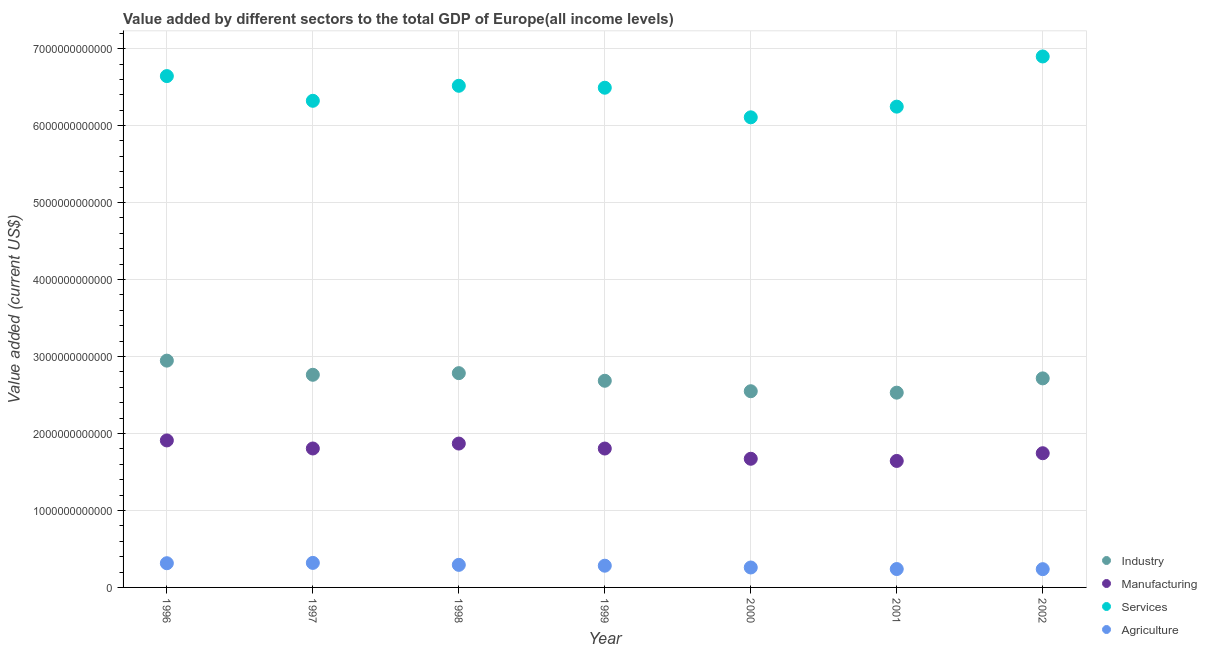How many different coloured dotlines are there?
Ensure brevity in your answer.  4. What is the value added by manufacturing sector in 2000?
Give a very brief answer. 1.67e+12. Across all years, what is the maximum value added by manufacturing sector?
Provide a short and direct response. 1.91e+12. Across all years, what is the minimum value added by agricultural sector?
Give a very brief answer. 2.37e+11. In which year was the value added by manufacturing sector maximum?
Offer a terse response. 1996. In which year was the value added by agricultural sector minimum?
Provide a succinct answer. 2002. What is the total value added by services sector in the graph?
Offer a very short reply. 4.52e+13. What is the difference between the value added by manufacturing sector in 1998 and that in 1999?
Your answer should be compact. 6.47e+1. What is the difference between the value added by industrial sector in 1999 and the value added by manufacturing sector in 2002?
Keep it short and to the point. 9.41e+11. What is the average value added by industrial sector per year?
Provide a short and direct response. 2.71e+12. In the year 2001, what is the difference between the value added by industrial sector and value added by services sector?
Offer a very short reply. -3.72e+12. In how many years, is the value added by agricultural sector greater than 7000000000000 US$?
Provide a short and direct response. 0. What is the ratio of the value added by services sector in 1996 to that in 1997?
Provide a succinct answer. 1.05. Is the difference between the value added by manufacturing sector in 1999 and 2000 greater than the difference between the value added by agricultural sector in 1999 and 2000?
Ensure brevity in your answer.  Yes. What is the difference between the highest and the second highest value added by manufacturing sector?
Provide a succinct answer. 4.05e+1. What is the difference between the highest and the lowest value added by services sector?
Your response must be concise. 7.91e+11. In how many years, is the value added by agricultural sector greater than the average value added by agricultural sector taken over all years?
Keep it short and to the point. 4. Is the sum of the value added by manufacturing sector in 2001 and 2002 greater than the maximum value added by industrial sector across all years?
Give a very brief answer. Yes. Is the value added by agricultural sector strictly greater than the value added by manufacturing sector over the years?
Make the answer very short. No. Is the value added by industrial sector strictly less than the value added by agricultural sector over the years?
Keep it short and to the point. No. What is the difference between two consecutive major ticks on the Y-axis?
Give a very brief answer. 1.00e+12. Are the values on the major ticks of Y-axis written in scientific E-notation?
Keep it short and to the point. No. Does the graph contain grids?
Provide a short and direct response. Yes. Where does the legend appear in the graph?
Keep it short and to the point. Bottom right. What is the title of the graph?
Your answer should be very brief. Value added by different sectors to the total GDP of Europe(all income levels). Does "CO2 damage" appear as one of the legend labels in the graph?
Give a very brief answer. No. What is the label or title of the X-axis?
Your response must be concise. Year. What is the label or title of the Y-axis?
Offer a very short reply. Value added (current US$). What is the Value added (current US$) in Industry in 1996?
Keep it short and to the point. 2.95e+12. What is the Value added (current US$) of Manufacturing in 1996?
Ensure brevity in your answer.  1.91e+12. What is the Value added (current US$) in Services in 1996?
Your response must be concise. 6.64e+12. What is the Value added (current US$) in Agriculture in 1996?
Your response must be concise. 3.15e+11. What is the Value added (current US$) of Industry in 1997?
Offer a terse response. 2.76e+12. What is the Value added (current US$) of Manufacturing in 1997?
Provide a succinct answer. 1.81e+12. What is the Value added (current US$) in Services in 1997?
Provide a short and direct response. 6.32e+12. What is the Value added (current US$) in Agriculture in 1997?
Your answer should be compact. 3.19e+11. What is the Value added (current US$) of Industry in 1998?
Keep it short and to the point. 2.78e+12. What is the Value added (current US$) of Manufacturing in 1998?
Give a very brief answer. 1.87e+12. What is the Value added (current US$) of Services in 1998?
Provide a succinct answer. 6.52e+12. What is the Value added (current US$) of Agriculture in 1998?
Make the answer very short. 2.93e+11. What is the Value added (current US$) in Industry in 1999?
Keep it short and to the point. 2.68e+12. What is the Value added (current US$) of Manufacturing in 1999?
Ensure brevity in your answer.  1.80e+12. What is the Value added (current US$) of Services in 1999?
Your response must be concise. 6.49e+12. What is the Value added (current US$) in Agriculture in 1999?
Provide a succinct answer. 2.82e+11. What is the Value added (current US$) in Industry in 2000?
Provide a succinct answer. 2.55e+12. What is the Value added (current US$) of Manufacturing in 2000?
Offer a very short reply. 1.67e+12. What is the Value added (current US$) of Services in 2000?
Your answer should be very brief. 6.11e+12. What is the Value added (current US$) in Agriculture in 2000?
Your response must be concise. 2.59e+11. What is the Value added (current US$) in Industry in 2001?
Offer a very short reply. 2.53e+12. What is the Value added (current US$) of Manufacturing in 2001?
Your response must be concise. 1.64e+12. What is the Value added (current US$) in Services in 2001?
Provide a short and direct response. 6.25e+12. What is the Value added (current US$) of Agriculture in 2001?
Offer a very short reply. 2.39e+11. What is the Value added (current US$) of Industry in 2002?
Keep it short and to the point. 2.72e+12. What is the Value added (current US$) in Manufacturing in 2002?
Make the answer very short. 1.74e+12. What is the Value added (current US$) of Services in 2002?
Keep it short and to the point. 6.90e+12. What is the Value added (current US$) in Agriculture in 2002?
Provide a short and direct response. 2.37e+11. Across all years, what is the maximum Value added (current US$) in Industry?
Provide a short and direct response. 2.95e+12. Across all years, what is the maximum Value added (current US$) in Manufacturing?
Your response must be concise. 1.91e+12. Across all years, what is the maximum Value added (current US$) in Services?
Keep it short and to the point. 6.90e+12. Across all years, what is the maximum Value added (current US$) of Agriculture?
Offer a very short reply. 3.19e+11. Across all years, what is the minimum Value added (current US$) of Industry?
Ensure brevity in your answer.  2.53e+12. Across all years, what is the minimum Value added (current US$) in Manufacturing?
Provide a succinct answer. 1.64e+12. Across all years, what is the minimum Value added (current US$) of Services?
Offer a very short reply. 6.11e+12. Across all years, what is the minimum Value added (current US$) in Agriculture?
Offer a very short reply. 2.37e+11. What is the total Value added (current US$) in Industry in the graph?
Offer a terse response. 1.90e+13. What is the total Value added (current US$) in Manufacturing in the graph?
Your response must be concise. 1.24e+13. What is the total Value added (current US$) in Services in the graph?
Ensure brevity in your answer.  4.52e+13. What is the total Value added (current US$) of Agriculture in the graph?
Give a very brief answer. 1.94e+12. What is the difference between the Value added (current US$) of Industry in 1996 and that in 1997?
Your answer should be compact. 1.84e+11. What is the difference between the Value added (current US$) in Manufacturing in 1996 and that in 1997?
Your answer should be compact. 1.05e+11. What is the difference between the Value added (current US$) in Services in 1996 and that in 1997?
Ensure brevity in your answer.  3.21e+11. What is the difference between the Value added (current US$) in Agriculture in 1996 and that in 1997?
Offer a very short reply. -4.16e+09. What is the difference between the Value added (current US$) of Industry in 1996 and that in 1998?
Provide a succinct answer. 1.63e+11. What is the difference between the Value added (current US$) of Manufacturing in 1996 and that in 1998?
Offer a terse response. 4.05e+1. What is the difference between the Value added (current US$) in Services in 1996 and that in 1998?
Make the answer very short. 1.26e+11. What is the difference between the Value added (current US$) in Agriculture in 1996 and that in 1998?
Your answer should be compact. 2.14e+1. What is the difference between the Value added (current US$) in Industry in 1996 and that in 1999?
Provide a succinct answer. 2.62e+11. What is the difference between the Value added (current US$) in Manufacturing in 1996 and that in 1999?
Make the answer very short. 1.05e+11. What is the difference between the Value added (current US$) of Services in 1996 and that in 1999?
Your response must be concise. 1.51e+11. What is the difference between the Value added (current US$) of Agriculture in 1996 and that in 1999?
Keep it short and to the point. 3.23e+1. What is the difference between the Value added (current US$) of Industry in 1996 and that in 2000?
Provide a short and direct response. 3.97e+11. What is the difference between the Value added (current US$) of Manufacturing in 1996 and that in 2000?
Your answer should be compact. 2.38e+11. What is the difference between the Value added (current US$) in Services in 1996 and that in 2000?
Make the answer very short. 5.36e+11. What is the difference between the Value added (current US$) in Agriculture in 1996 and that in 2000?
Make the answer very short. 5.55e+1. What is the difference between the Value added (current US$) of Industry in 1996 and that in 2001?
Give a very brief answer. 4.16e+11. What is the difference between the Value added (current US$) in Manufacturing in 1996 and that in 2001?
Offer a terse response. 2.66e+11. What is the difference between the Value added (current US$) of Services in 1996 and that in 2001?
Ensure brevity in your answer.  3.97e+11. What is the difference between the Value added (current US$) in Agriculture in 1996 and that in 2001?
Give a very brief answer. 7.57e+1. What is the difference between the Value added (current US$) in Industry in 1996 and that in 2002?
Your answer should be very brief. 2.31e+11. What is the difference between the Value added (current US$) in Manufacturing in 1996 and that in 2002?
Keep it short and to the point. 1.66e+11. What is the difference between the Value added (current US$) in Services in 1996 and that in 2002?
Your answer should be very brief. -2.55e+11. What is the difference between the Value added (current US$) in Agriculture in 1996 and that in 2002?
Offer a very short reply. 7.74e+1. What is the difference between the Value added (current US$) in Industry in 1997 and that in 1998?
Offer a very short reply. -2.12e+1. What is the difference between the Value added (current US$) in Manufacturing in 1997 and that in 1998?
Your response must be concise. -6.41e+1. What is the difference between the Value added (current US$) in Services in 1997 and that in 1998?
Your answer should be very brief. -1.95e+11. What is the difference between the Value added (current US$) in Agriculture in 1997 and that in 1998?
Your answer should be very brief. 2.56e+1. What is the difference between the Value added (current US$) in Industry in 1997 and that in 1999?
Make the answer very short. 7.77e+1. What is the difference between the Value added (current US$) of Manufacturing in 1997 and that in 1999?
Provide a succinct answer. 5.84e+08. What is the difference between the Value added (current US$) of Services in 1997 and that in 1999?
Your response must be concise. -1.70e+11. What is the difference between the Value added (current US$) in Agriculture in 1997 and that in 1999?
Your response must be concise. 3.65e+1. What is the difference between the Value added (current US$) in Industry in 1997 and that in 2000?
Give a very brief answer. 2.14e+11. What is the difference between the Value added (current US$) in Manufacturing in 1997 and that in 2000?
Your answer should be compact. 1.34e+11. What is the difference between the Value added (current US$) in Services in 1997 and that in 2000?
Offer a terse response. 2.15e+11. What is the difference between the Value added (current US$) of Agriculture in 1997 and that in 2000?
Give a very brief answer. 5.97e+1. What is the difference between the Value added (current US$) of Industry in 1997 and that in 2001?
Your answer should be compact. 2.32e+11. What is the difference between the Value added (current US$) of Manufacturing in 1997 and that in 2001?
Your response must be concise. 1.62e+11. What is the difference between the Value added (current US$) in Services in 1997 and that in 2001?
Offer a very short reply. 7.59e+1. What is the difference between the Value added (current US$) of Agriculture in 1997 and that in 2001?
Ensure brevity in your answer.  7.99e+1. What is the difference between the Value added (current US$) of Industry in 1997 and that in 2002?
Your answer should be compact. 4.67e+1. What is the difference between the Value added (current US$) of Manufacturing in 1997 and that in 2002?
Give a very brief answer. 6.15e+1. What is the difference between the Value added (current US$) of Services in 1997 and that in 2002?
Provide a short and direct response. -5.76e+11. What is the difference between the Value added (current US$) of Agriculture in 1997 and that in 2002?
Ensure brevity in your answer.  8.15e+1. What is the difference between the Value added (current US$) of Industry in 1998 and that in 1999?
Provide a succinct answer. 9.90e+1. What is the difference between the Value added (current US$) in Manufacturing in 1998 and that in 1999?
Your answer should be very brief. 6.47e+1. What is the difference between the Value added (current US$) in Services in 1998 and that in 1999?
Your response must be concise. 2.53e+1. What is the difference between the Value added (current US$) of Agriculture in 1998 and that in 1999?
Keep it short and to the point. 1.09e+1. What is the difference between the Value added (current US$) in Industry in 1998 and that in 2000?
Offer a terse response. 2.35e+11. What is the difference between the Value added (current US$) in Manufacturing in 1998 and that in 2000?
Keep it short and to the point. 1.98e+11. What is the difference between the Value added (current US$) of Services in 1998 and that in 2000?
Offer a very short reply. 4.10e+11. What is the difference between the Value added (current US$) in Agriculture in 1998 and that in 2000?
Your response must be concise. 3.41e+1. What is the difference between the Value added (current US$) of Industry in 1998 and that in 2001?
Your answer should be very brief. 2.53e+11. What is the difference between the Value added (current US$) of Manufacturing in 1998 and that in 2001?
Your answer should be compact. 2.26e+11. What is the difference between the Value added (current US$) of Services in 1998 and that in 2001?
Offer a very short reply. 2.71e+11. What is the difference between the Value added (current US$) of Agriculture in 1998 and that in 2001?
Offer a very short reply. 5.43e+1. What is the difference between the Value added (current US$) of Industry in 1998 and that in 2002?
Offer a very short reply. 6.79e+1. What is the difference between the Value added (current US$) of Manufacturing in 1998 and that in 2002?
Your response must be concise. 1.26e+11. What is the difference between the Value added (current US$) of Services in 1998 and that in 2002?
Provide a short and direct response. -3.81e+11. What is the difference between the Value added (current US$) in Agriculture in 1998 and that in 2002?
Offer a very short reply. 5.60e+1. What is the difference between the Value added (current US$) in Industry in 1999 and that in 2000?
Your answer should be compact. 1.36e+11. What is the difference between the Value added (current US$) in Manufacturing in 1999 and that in 2000?
Ensure brevity in your answer.  1.33e+11. What is the difference between the Value added (current US$) of Services in 1999 and that in 2000?
Give a very brief answer. 3.84e+11. What is the difference between the Value added (current US$) of Agriculture in 1999 and that in 2000?
Give a very brief answer. 2.32e+1. What is the difference between the Value added (current US$) of Industry in 1999 and that in 2001?
Your response must be concise. 1.54e+11. What is the difference between the Value added (current US$) in Manufacturing in 1999 and that in 2001?
Provide a short and direct response. 1.61e+11. What is the difference between the Value added (current US$) of Services in 1999 and that in 2001?
Give a very brief answer. 2.46e+11. What is the difference between the Value added (current US$) of Agriculture in 1999 and that in 2001?
Offer a terse response. 4.34e+1. What is the difference between the Value added (current US$) of Industry in 1999 and that in 2002?
Offer a very short reply. -3.11e+1. What is the difference between the Value added (current US$) of Manufacturing in 1999 and that in 2002?
Offer a very short reply. 6.09e+1. What is the difference between the Value added (current US$) in Services in 1999 and that in 2002?
Keep it short and to the point. -4.06e+11. What is the difference between the Value added (current US$) of Agriculture in 1999 and that in 2002?
Offer a terse response. 4.50e+1. What is the difference between the Value added (current US$) in Industry in 2000 and that in 2001?
Your response must be concise. 1.86e+1. What is the difference between the Value added (current US$) of Manufacturing in 2000 and that in 2001?
Your answer should be very brief. 2.82e+1. What is the difference between the Value added (current US$) in Services in 2000 and that in 2001?
Give a very brief answer. -1.39e+11. What is the difference between the Value added (current US$) in Agriculture in 2000 and that in 2001?
Keep it short and to the point. 2.02e+1. What is the difference between the Value added (current US$) of Industry in 2000 and that in 2002?
Make the answer very short. -1.67e+11. What is the difference between the Value added (current US$) of Manufacturing in 2000 and that in 2002?
Ensure brevity in your answer.  -7.21e+1. What is the difference between the Value added (current US$) in Services in 2000 and that in 2002?
Keep it short and to the point. -7.91e+11. What is the difference between the Value added (current US$) in Agriculture in 2000 and that in 2002?
Your response must be concise. 2.18e+1. What is the difference between the Value added (current US$) in Industry in 2001 and that in 2002?
Ensure brevity in your answer.  -1.85e+11. What is the difference between the Value added (current US$) in Manufacturing in 2001 and that in 2002?
Make the answer very short. -1.00e+11. What is the difference between the Value added (current US$) in Services in 2001 and that in 2002?
Your response must be concise. -6.52e+11. What is the difference between the Value added (current US$) in Agriculture in 2001 and that in 2002?
Your answer should be compact. 1.61e+09. What is the difference between the Value added (current US$) of Industry in 1996 and the Value added (current US$) of Manufacturing in 1997?
Provide a short and direct response. 1.14e+12. What is the difference between the Value added (current US$) of Industry in 1996 and the Value added (current US$) of Services in 1997?
Keep it short and to the point. -3.38e+12. What is the difference between the Value added (current US$) of Industry in 1996 and the Value added (current US$) of Agriculture in 1997?
Ensure brevity in your answer.  2.63e+12. What is the difference between the Value added (current US$) in Manufacturing in 1996 and the Value added (current US$) in Services in 1997?
Make the answer very short. -4.41e+12. What is the difference between the Value added (current US$) in Manufacturing in 1996 and the Value added (current US$) in Agriculture in 1997?
Your answer should be compact. 1.59e+12. What is the difference between the Value added (current US$) in Services in 1996 and the Value added (current US$) in Agriculture in 1997?
Keep it short and to the point. 6.32e+12. What is the difference between the Value added (current US$) of Industry in 1996 and the Value added (current US$) of Manufacturing in 1998?
Your response must be concise. 1.08e+12. What is the difference between the Value added (current US$) of Industry in 1996 and the Value added (current US$) of Services in 1998?
Your response must be concise. -3.57e+12. What is the difference between the Value added (current US$) in Industry in 1996 and the Value added (current US$) in Agriculture in 1998?
Offer a very short reply. 2.65e+12. What is the difference between the Value added (current US$) of Manufacturing in 1996 and the Value added (current US$) of Services in 1998?
Your response must be concise. -4.61e+12. What is the difference between the Value added (current US$) of Manufacturing in 1996 and the Value added (current US$) of Agriculture in 1998?
Give a very brief answer. 1.62e+12. What is the difference between the Value added (current US$) in Services in 1996 and the Value added (current US$) in Agriculture in 1998?
Your answer should be compact. 6.35e+12. What is the difference between the Value added (current US$) in Industry in 1996 and the Value added (current US$) in Manufacturing in 1999?
Make the answer very short. 1.14e+12. What is the difference between the Value added (current US$) in Industry in 1996 and the Value added (current US$) in Services in 1999?
Provide a short and direct response. -3.55e+12. What is the difference between the Value added (current US$) of Industry in 1996 and the Value added (current US$) of Agriculture in 1999?
Give a very brief answer. 2.66e+12. What is the difference between the Value added (current US$) of Manufacturing in 1996 and the Value added (current US$) of Services in 1999?
Make the answer very short. -4.58e+12. What is the difference between the Value added (current US$) in Manufacturing in 1996 and the Value added (current US$) in Agriculture in 1999?
Make the answer very short. 1.63e+12. What is the difference between the Value added (current US$) in Services in 1996 and the Value added (current US$) in Agriculture in 1999?
Keep it short and to the point. 6.36e+12. What is the difference between the Value added (current US$) of Industry in 1996 and the Value added (current US$) of Manufacturing in 2000?
Keep it short and to the point. 1.27e+12. What is the difference between the Value added (current US$) of Industry in 1996 and the Value added (current US$) of Services in 2000?
Ensure brevity in your answer.  -3.16e+12. What is the difference between the Value added (current US$) in Industry in 1996 and the Value added (current US$) in Agriculture in 2000?
Ensure brevity in your answer.  2.69e+12. What is the difference between the Value added (current US$) in Manufacturing in 1996 and the Value added (current US$) in Services in 2000?
Provide a short and direct response. -4.20e+12. What is the difference between the Value added (current US$) of Manufacturing in 1996 and the Value added (current US$) of Agriculture in 2000?
Offer a terse response. 1.65e+12. What is the difference between the Value added (current US$) of Services in 1996 and the Value added (current US$) of Agriculture in 2000?
Keep it short and to the point. 6.38e+12. What is the difference between the Value added (current US$) of Industry in 1996 and the Value added (current US$) of Manufacturing in 2001?
Your answer should be very brief. 1.30e+12. What is the difference between the Value added (current US$) in Industry in 1996 and the Value added (current US$) in Services in 2001?
Your answer should be very brief. -3.30e+12. What is the difference between the Value added (current US$) of Industry in 1996 and the Value added (current US$) of Agriculture in 2001?
Your answer should be very brief. 2.71e+12. What is the difference between the Value added (current US$) in Manufacturing in 1996 and the Value added (current US$) in Services in 2001?
Offer a very short reply. -4.34e+12. What is the difference between the Value added (current US$) of Manufacturing in 1996 and the Value added (current US$) of Agriculture in 2001?
Provide a short and direct response. 1.67e+12. What is the difference between the Value added (current US$) of Services in 1996 and the Value added (current US$) of Agriculture in 2001?
Provide a short and direct response. 6.40e+12. What is the difference between the Value added (current US$) in Industry in 1996 and the Value added (current US$) in Manufacturing in 2002?
Your answer should be very brief. 1.20e+12. What is the difference between the Value added (current US$) in Industry in 1996 and the Value added (current US$) in Services in 2002?
Ensure brevity in your answer.  -3.95e+12. What is the difference between the Value added (current US$) in Industry in 1996 and the Value added (current US$) in Agriculture in 2002?
Give a very brief answer. 2.71e+12. What is the difference between the Value added (current US$) of Manufacturing in 1996 and the Value added (current US$) of Services in 2002?
Provide a succinct answer. -4.99e+12. What is the difference between the Value added (current US$) in Manufacturing in 1996 and the Value added (current US$) in Agriculture in 2002?
Provide a short and direct response. 1.67e+12. What is the difference between the Value added (current US$) in Services in 1996 and the Value added (current US$) in Agriculture in 2002?
Your answer should be very brief. 6.41e+12. What is the difference between the Value added (current US$) of Industry in 1997 and the Value added (current US$) of Manufacturing in 1998?
Offer a very short reply. 8.93e+11. What is the difference between the Value added (current US$) of Industry in 1997 and the Value added (current US$) of Services in 1998?
Ensure brevity in your answer.  -3.75e+12. What is the difference between the Value added (current US$) of Industry in 1997 and the Value added (current US$) of Agriculture in 1998?
Keep it short and to the point. 2.47e+12. What is the difference between the Value added (current US$) in Manufacturing in 1997 and the Value added (current US$) in Services in 1998?
Give a very brief answer. -4.71e+12. What is the difference between the Value added (current US$) of Manufacturing in 1997 and the Value added (current US$) of Agriculture in 1998?
Make the answer very short. 1.51e+12. What is the difference between the Value added (current US$) of Services in 1997 and the Value added (current US$) of Agriculture in 1998?
Provide a succinct answer. 6.03e+12. What is the difference between the Value added (current US$) in Industry in 1997 and the Value added (current US$) in Manufacturing in 1999?
Your response must be concise. 9.58e+11. What is the difference between the Value added (current US$) in Industry in 1997 and the Value added (current US$) in Services in 1999?
Offer a very short reply. -3.73e+12. What is the difference between the Value added (current US$) in Industry in 1997 and the Value added (current US$) in Agriculture in 1999?
Your answer should be compact. 2.48e+12. What is the difference between the Value added (current US$) in Manufacturing in 1997 and the Value added (current US$) in Services in 1999?
Make the answer very short. -4.69e+12. What is the difference between the Value added (current US$) in Manufacturing in 1997 and the Value added (current US$) in Agriculture in 1999?
Provide a short and direct response. 1.52e+12. What is the difference between the Value added (current US$) in Services in 1997 and the Value added (current US$) in Agriculture in 1999?
Your answer should be compact. 6.04e+12. What is the difference between the Value added (current US$) in Industry in 1997 and the Value added (current US$) in Manufacturing in 2000?
Offer a very short reply. 1.09e+12. What is the difference between the Value added (current US$) in Industry in 1997 and the Value added (current US$) in Services in 2000?
Your answer should be compact. -3.35e+12. What is the difference between the Value added (current US$) of Industry in 1997 and the Value added (current US$) of Agriculture in 2000?
Provide a succinct answer. 2.50e+12. What is the difference between the Value added (current US$) of Manufacturing in 1997 and the Value added (current US$) of Services in 2000?
Keep it short and to the point. -4.30e+12. What is the difference between the Value added (current US$) of Manufacturing in 1997 and the Value added (current US$) of Agriculture in 2000?
Provide a short and direct response. 1.55e+12. What is the difference between the Value added (current US$) in Services in 1997 and the Value added (current US$) in Agriculture in 2000?
Keep it short and to the point. 6.06e+12. What is the difference between the Value added (current US$) of Industry in 1997 and the Value added (current US$) of Manufacturing in 2001?
Provide a succinct answer. 1.12e+12. What is the difference between the Value added (current US$) in Industry in 1997 and the Value added (current US$) in Services in 2001?
Give a very brief answer. -3.48e+12. What is the difference between the Value added (current US$) of Industry in 1997 and the Value added (current US$) of Agriculture in 2001?
Make the answer very short. 2.52e+12. What is the difference between the Value added (current US$) of Manufacturing in 1997 and the Value added (current US$) of Services in 2001?
Provide a short and direct response. -4.44e+12. What is the difference between the Value added (current US$) in Manufacturing in 1997 and the Value added (current US$) in Agriculture in 2001?
Your answer should be compact. 1.57e+12. What is the difference between the Value added (current US$) of Services in 1997 and the Value added (current US$) of Agriculture in 2001?
Provide a short and direct response. 6.08e+12. What is the difference between the Value added (current US$) of Industry in 1997 and the Value added (current US$) of Manufacturing in 2002?
Ensure brevity in your answer.  1.02e+12. What is the difference between the Value added (current US$) of Industry in 1997 and the Value added (current US$) of Services in 2002?
Make the answer very short. -4.14e+12. What is the difference between the Value added (current US$) of Industry in 1997 and the Value added (current US$) of Agriculture in 2002?
Your response must be concise. 2.53e+12. What is the difference between the Value added (current US$) in Manufacturing in 1997 and the Value added (current US$) in Services in 2002?
Ensure brevity in your answer.  -5.09e+12. What is the difference between the Value added (current US$) of Manufacturing in 1997 and the Value added (current US$) of Agriculture in 2002?
Make the answer very short. 1.57e+12. What is the difference between the Value added (current US$) of Services in 1997 and the Value added (current US$) of Agriculture in 2002?
Give a very brief answer. 6.09e+12. What is the difference between the Value added (current US$) of Industry in 1998 and the Value added (current US$) of Manufacturing in 1999?
Ensure brevity in your answer.  9.79e+11. What is the difference between the Value added (current US$) in Industry in 1998 and the Value added (current US$) in Services in 1999?
Your answer should be very brief. -3.71e+12. What is the difference between the Value added (current US$) of Industry in 1998 and the Value added (current US$) of Agriculture in 1999?
Offer a very short reply. 2.50e+12. What is the difference between the Value added (current US$) of Manufacturing in 1998 and the Value added (current US$) of Services in 1999?
Keep it short and to the point. -4.62e+12. What is the difference between the Value added (current US$) in Manufacturing in 1998 and the Value added (current US$) in Agriculture in 1999?
Give a very brief answer. 1.59e+12. What is the difference between the Value added (current US$) of Services in 1998 and the Value added (current US$) of Agriculture in 1999?
Keep it short and to the point. 6.24e+12. What is the difference between the Value added (current US$) of Industry in 1998 and the Value added (current US$) of Manufacturing in 2000?
Provide a succinct answer. 1.11e+12. What is the difference between the Value added (current US$) of Industry in 1998 and the Value added (current US$) of Services in 2000?
Offer a terse response. -3.32e+12. What is the difference between the Value added (current US$) of Industry in 1998 and the Value added (current US$) of Agriculture in 2000?
Offer a very short reply. 2.52e+12. What is the difference between the Value added (current US$) of Manufacturing in 1998 and the Value added (current US$) of Services in 2000?
Your answer should be very brief. -4.24e+12. What is the difference between the Value added (current US$) in Manufacturing in 1998 and the Value added (current US$) in Agriculture in 2000?
Your answer should be very brief. 1.61e+12. What is the difference between the Value added (current US$) in Services in 1998 and the Value added (current US$) in Agriculture in 2000?
Provide a short and direct response. 6.26e+12. What is the difference between the Value added (current US$) in Industry in 1998 and the Value added (current US$) in Manufacturing in 2001?
Offer a very short reply. 1.14e+12. What is the difference between the Value added (current US$) of Industry in 1998 and the Value added (current US$) of Services in 2001?
Your answer should be very brief. -3.46e+12. What is the difference between the Value added (current US$) of Industry in 1998 and the Value added (current US$) of Agriculture in 2001?
Offer a very short reply. 2.55e+12. What is the difference between the Value added (current US$) in Manufacturing in 1998 and the Value added (current US$) in Services in 2001?
Your response must be concise. -4.38e+12. What is the difference between the Value added (current US$) of Manufacturing in 1998 and the Value added (current US$) of Agriculture in 2001?
Give a very brief answer. 1.63e+12. What is the difference between the Value added (current US$) in Services in 1998 and the Value added (current US$) in Agriculture in 2001?
Offer a very short reply. 6.28e+12. What is the difference between the Value added (current US$) in Industry in 1998 and the Value added (current US$) in Manufacturing in 2002?
Make the answer very short. 1.04e+12. What is the difference between the Value added (current US$) of Industry in 1998 and the Value added (current US$) of Services in 2002?
Provide a short and direct response. -4.11e+12. What is the difference between the Value added (current US$) in Industry in 1998 and the Value added (current US$) in Agriculture in 2002?
Give a very brief answer. 2.55e+12. What is the difference between the Value added (current US$) in Manufacturing in 1998 and the Value added (current US$) in Services in 2002?
Provide a succinct answer. -5.03e+12. What is the difference between the Value added (current US$) in Manufacturing in 1998 and the Value added (current US$) in Agriculture in 2002?
Give a very brief answer. 1.63e+12. What is the difference between the Value added (current US$) in Services in 1998 and the Value added (current US$) in Agriculture in 2002?
Provide a short and direct response. 6.28e+12. What is the difference between the Value added (current US$) of Industry in 1999 and the Value added (current US$) of Manufacturing in 2000?
Your response must be concise. 1.01e+12. What is the difference between the Value added (current US$) of Industry in 1999 and the Value added (current US$) of Services in 2000?
Provide a short and direct response. -3.42e+12. What is the difference between the Value added (current US$) of Industry in 1999 and the Value added (current US$) of Agriculture in 2000?
Ensure brevity in your answer.  2.43e+12. What is the difference between the Value added (current US$) in Manufacturing in 1999 and the Value added (current US$) in Services in 2000?
Give a very brief answer. -4.30e+12. What is the difference between the Value added (current US$) of Manufacturing in 1999 and the Value added (current US$) of Agriculture in 2000?
Ensure brevity in your answer.  1.55e+12. What is the difference between the Value added (current US$) of Services in 1999 and the Value added (current US$) of Agriculture in 2000?
Make the answer very short. 6.23e+12. What is the difference between the Value added (current US$) of Industry in 1999 and the Value added (current US$) of Manufacturing in 2001?
Provide a short and direct response. 1.04e+12. What is the difference between the Value added (current US$) of Industry in 1999 and the Value added (current US$) of Services in 2001?
Ensure brevity in your answer.  -3.56e+12. What is the difference between the Value added (current US$) of Industry in 1999 and the Value added (current US$) of Agriculture in 2001?
Provide a short and direct response. 2.45e+12. What is the difference between the Value added (current US$) of Manufacturing in 1999 and the Value added (current US$) of Services in 2001?
Your answer should be compact. -4.44e+12. What is the difference between the Value added (current US$) of Manufacturing in 1999 and the Value added (current US$) of Agriculture in 2001?
Keep it short and to the point. 1.57e+12. What is the difference between the Value added (current US$) of Services in 1999 and the Value added (current US$) of Agriculture in 2001?
Ensure brevity in your answer.  6.25e+12. What is the difference between the Value added (current US$) in Industry in 1999 and the Value added (current US$) in Manufacturing in 2002?
Your response must be concise. 9.41e+11. What is the difference between the Value added (current US$) in Industry in 1999 and the Value added (current US$) in Services in 2002?
Provide a short and direct response. -4.21e+12. What is the difference between the Value added (current US$) of Industry in 1999 and the Value added (current US$) of Agriculture in 2002?
Provide a short and direct response. 2.45e+12. What is the difference between the Value added (current US$) in Manufacturing in 1999 and the Value added (current US$) in Services in 2002?
Your response must be concise. -5.09e+12. What is the difference between the Value added (current US$) in Manufacturing in 1999 and the Value added (current US$) in Agriculture in 2002?
Provide a short and direct response. 1.57e+12. What is the difference between the Value added (current US$) of Services in 1999 and the Value added (current US$) of Agriculture in 2002?
Your answer should be very brief. 6.25e+12. What is the difference between the Value added (current US$) in Industry in 2000 and the Value added (current US$) in Manufacturing in 2001?
Keep it short and to the point. 9.06e+11. What is the difference between the Value added (current US$) in Industry in 2000 and the Value added (current US$) in Services in 2001?
Your answer should be very brief. -3.70e+12. What is the difference between the Value added (current US$) in Industry in 2000 and the Value added (current US$) in Agriculture in 2001?
Your response must be concise. 2.31e+12. What is the difference between the Value added (current US$) in Manufacturing in 2000 and the Value added (current US$) in Services in 2001?
Offer a very short reply. -4.57e+12. What is the difference between the Value added (current US$) of Manufacturing in 2000 and the Value added (current US$) of Agriculture in 2001?
Ensure brevity in your answer.  1.43e+12. What is the difference between the Value added (current US$) of Services in 2000 and the Value added (current US$) of Agriculture in 2001?
Your answer should be very brief. 5.87e+12. What is the difference between the Value added (current US$) of Industry in 2000 and the Value added (current US$) of Manufacturing in 2002?
Provide a short and direct response. 8.05e+11. What is the difference between the Value added (current US$) of Industry in 2000 and the Value added (current US$) of Services in 2002?
Give a very brief answer. -4.35e+12. What is the difference between the Value added (current US$) in Industry in 2000 and the Value added (current US$) in Agriculture in 2002?
Offer a terse response. 2.31e+12. What is the difference between the Value added (current US$) in Manufacturing in 2000 and the Value added (current US$) in Services in 2002?
Keep it short and to the point. -5.23e+12. What is the difference between the Value added (current US$) in Manufacturing in 2000 and the Value added (current US$) in Agriculture in 2002?
Your response must be concise. 1.43e+12. What is the difference between the Value added (current US$) of Services in 2000 and the Value added (current US$) of Agriculture in 2002?
Provide a short and direct response. 5.87e+12. What is the difference between the Value added (current US$) of Industry in 2001 and the Value added (current US$) of Manufacturing in 2002?
Ensure brevity in your answer.  7.87e+11. What is the difference between the Value added (current US$) in Industry in 2001 and the Value added (current US$) in Services in 2002?
Your answer should be very brief. -4.37e+12. What is the difference between the Value added (current US$) in Industry in 2001 and the Value added (current US$) in Agriculture in 2002?
Keep it short and to the point. 2.29e+12. What is the difference between the Value added (current US$) in Manufacturing in 2001 and the Value added (current US$) in Services in 2002?
Your response must be concise. -5.25e+12. What is the difference between the Value added (current US$) in Manufacturing in 2001 and the Value added (current US$) in Agriculture in 2002?
Keep it short and to the point. 1.41e+12. What is the difference between the Value added (current US$) of Services in 2001 and the Value added (current US$) of Agriculture in 2002?
Your response must be concise. 6.01e+12. What is the average Value added (current US$) in Industry per year?
Offer a terse response. 2.71e+12. What is the average Value added (current US$) in Manufacturing per year?
Give a very brief answer. 1.78e+12. What is the average Value added (current US$) of Services per year?
Keep it short and to the point. 6.46e+12. What is the average Value added (current US$) in Agriculture per year?
Your answer should be compact. 2.78e+11. In the year 1996, what is the difference between the Value added (current US$) in Industry and Value added (current US$) in Manufacturing?
Provide a succinct answer. 1.04e+12. In the year 1996, what is the difference between the Value added (current US$) in Industry and Value added (current US$) in Services?
Offer a terse response. -3.70e+12. In the year 1996, what is the difference between the Value added (current US$) of Industry and Value added (current US$) of Agriculture?
Provide a short and direct response. 2.63e+12. In the year 1996, what is the difference between the Value added (current US$) of Manufacturing and Value added (current US$) of Services?
Your response must be concise. -4.73e+12. In the year 1996, what is the difference between the Value added (current US$) in Manufacturing and Value added (current US$) in Agriculture?
Offer a terse response. 1.60e+12. In the year 1996, what is the difference between the Value added (current US$) of Services and Value added (current US$) of Agriculture?
Offer a very short reply. 6.33e+12. In the year 1997, what is the difference between the Value added (current US$) of Industry and Value added (current US$) of Manufacturing?
Provide a short and direct response. 9.57e+11. In the year 1997, what is the difference between the Value added (current US$) in Industry and Value added (current US$) in Services?
Ensure brevity in your answer.  -3.56e+12. In the year 1997, what is the difference between the Value added (current US$) of Industry and Value added (current US$) of Agriculture?
Provide a short and direct response. 2.44e+12. In the year 1997, what is the difference between the Value added (current US$) of Manufacturing and Value added (current US$) of Services?
Provide a succinct answer. -4.52e+12. In the year 1997, what is the difference between the Value added (current US$) in Manufacturing and Value added (current US$) in Agriculture?
Your answer should be very brief. 1.49e+12. In the year 1997, what is the difference between the Value added (current US$) of Services and Value added (current US$) of Agriculture?
Your answer should be compact. 6.00e+12. In the year 1998, what is the difference between the Value added (current US$) in Industry and Value added (current US$) in Manufacturing?
Provide a short and direct response. 9.15e+11. In the year 1998, what is the difference between the Value added (current US$) in Industry and Value added (current US$) in Services?
Your response must be concise. -3.73e+12. In the year 1998, what is the difference between the Value added (current US$) in Industry and Value added (current US$) in Agriculture?
Offer a very short reply. 2.49e+12. In the year 1998, what is the difference between the Value added (current US$) in Manufacturing and Value added (current US$) in Services?
Ensure brevity in your answer.  -4.65e+12. In the year 1998, what is the difference between the Value added (current US$) in Manufacturing and Value added (current US$) in Agriculture?
Your answer should be very brief. 1.58e+12. In the year 1998, what is the difference between the Value added (current US$) in Services and Value added (current US$) in Agriculture?
Your answer should be compact. 6.22e+12. In the year 1999, what is the difference between the Value added (current US$) of Industry and Value added (current US$) of Manufacturing?
Provide a succinct answer. 8.80e+11. In the year 1999, what is the difference between the Value added (current US$) in Industry and Value added (current US$) in Services?
Provide a short and direct response. -3.81e+12. In the year 1999, what is the difference between the Value added (current US$) of Industry and Value added (current US$) of Agriculture?
Provide a succinct answer. 2.40e+12. In the year 1999, what is the difference between the Value added (current US$) in Manufacturing and Value added (current US$) in Services?
Provide a short and direct response. -4.69e+12. In the year 1999, what is the difference between the Value added (current US$) of Manufacturing and Value added (current US$) of Agriculture?
Keep it short and to the point. 1.52e+12. In the year 1999, what is the difference between the Value added (current US$) in Services and Value added (current US$) in Agriculture?
Provide a short and direct response. 6.21e+12. In the year 2000, what is the difference between the Value added (current US$) of Industry and Value added (current US$) of Manufacturing?
Your answer should be very brief. 8.77e+11. In the year 2000, what is the difference between the Value added (current US$) of Industry and Value added (current US$) of Services?
Your response must be concise. -3.56e+12. In the year 2000, what is the difference between the Value added (current US$) in Industry and Value added (current US$) in Agriculture?
Your response must be concise. 2.29e+12. In the year 2000, what is the difference between the Value added (current US$) in Manufacturing and Value added (current US$) in Services?
Your response must be concise. -4.44e+12. In the year 2000, what is the difference between the Value added (current US$) of Manufacturing and Value added (current US$) of Agriculture?
Keep it short and to the point. 1.41e+12. In the year 2000, what is the difference between the Value added (current US$) of Services and Value added (current US$) of Agriculture?
Offer a very short reply. 5.85e+12. In the year 2001, what is the difference between the Value added (current US$) in Industry and Value added (current US$) in Manufacturing?
Make the answer very short. 8.87e+11. In the year 2001, what is the difference between the Value added (current US$) of Industry and Value added (current US$) of Services?
Provide a succinct answer. -3.72e+12. In the year 2001, what is the difference between the Value added (current US$) in Industry and Value added (current US$) in Agriculture?
Keep it short and to the point. 2.29e+12. In the year 2001, what is the difference between the Value added (current US$) of Manufacturing and Value added (current US$) of Services?
Your answer should be very brief. -4.60e+12. In the year 2001, what is the difference between the Value added (current US$) in Manufacturing and Value added (current US$) in Agriculture?
Your response must be concise. 1.40e+12. In the year 2001, what is the difference between the Value added (current US$) of Services and Value added (current US$) of Agriculture?
Ensure brevity in your answer.  6.01e+12. In the year 2002, what is the difference between the Value added (current US$) of Industry and Value added (current US$) of Manufacturing?
Give a very brief answer. 9.72e+11. In the year 2002, what is the difference between the Value added (current US$) in Industry and Value added (current US$) in Services?
Give a very brief answer. -4.18e+12. In the year 2002, what is the difference between the Value added (current US$) of Industry and Value added (current US$) of Agriculture?
Keep it short and to the point. 2.48e+12. In the year 2002, what is the difference between the Value added (current US$) of Manufacturing and Value added (current US$) of Services?
Offer a very short reply. -5.15e+12. In the year 2002, what is the difference between the Value added (current US$) in Manufacturing and Value added (current US$) in Agriculture?
Make the answer very short. 1.51e+12. In the year 2002, what is the difference between the Value added (current US$) of Services and Value added (current US$) of Agriculture?
Offer a very short reply. 6.66e+12. What is the ratio of the Value added (current US$) of Industry in 1996 to that in 1997?
Make the answer very short. 1.07. What is the ratio of the Value added (current US$) of Manufacturing in 1996 to that in 1997?
Your answer should be very brief. 1.06. What is the ratio of the Value added (current US$) in Services in 1996 to that in 1997?
Provide a succinct answer. 1.05. What is the ratio of the Value added (current US$) of Agriculture in 1996 to that in 1997?
Your answer should be very brief. 0.99. What is the ratio of the Value added (current US$) in Industry in 1996 to that in 1998?
Offer a terse response. 1.06. What is the ratio of the Value added (current US$) of Manufacturing in 1996 to that in 1998?
Give a very brief answer. 1.02. What is the ratio of the Value added (current US$) of Services in 1996 to that in 1998?
Make the answer very short. 1.02. What is the ratio of the Value added (current US$) in Agriculture in 1996 to that in 1998?
Offer a very short reply. 1.07. What is the ratio of the Value added (current US$) in Industry in 1996 to that in 1999?
Provide a short and direct response. 1.1. What is the ratio of the Value added (current US$) in Manufacturing in 1996 to that in 1999?
Make the answer very short. 1.06. What is the ratio of the Value added (current US$) of Services in 1996 to that in 1999?
Your answer should be very brief. 1.02. What is the ratio of the Value added (current US$) of Agriculture in 1996 to that in 1999?
Provide a short and direct response. 1.11. What is the ratio of the Value added (current US$) of Industry in 1996 to that in 2000?
Provide a succinct answer. 1.16. What is the ratio of the Value added (current US$) in Manufacturing in 1996 to that in 2000?
Your response must be concise. 1.14. What is the ratio of the Value added (current US$) of Services in 1996 to that in 2000?
Offer a terse response. 1.09. What is the ratio of the Value added (current US$) of Agriculture in 1996 to that in 2000?
Give a very brief answer. 1.21. What is the ratio of the Value added (current US$) in Industry in 1996 to that in 2001?
Provide a succinct answer. 1.16. What is the ratio of the Value added (current US$) of Manufacturing in 1996 to that in 2001?
Your response must be concise. 1.16. What is the ratio of the Value added (current US$) of Services in 1996 to that in 2001?
Offer a very short reply. 1.06. What is the ratio of the Value added (current US$) of Agriculture in 1996 to that in 2001?
Your response must be concise. 1.32. What is the ratio of the Value added (current US$) in Industry in 1996 to that in 2002?
Make the answer very short. 1.08. What is the ratio of the Value added (current US$) in Manufacturing in 1996 to that in 2002?
Provide a succinct answer. 1.1. What is the ratio of the Value added (current US$) of Services in 1996 to that in 2002?
Make the answer very short. 0.96. What is the ratio of the Value added (current US$) of Agriculture in 1996 to that in 2002?
Your answer should be very brief. 1.33. What is the ratio of the Value added (current US$) of Industry in 1997 to that in 1998?
Your answer should be very brief. 0.99. What is the ratio of the Value added (current US$) of Manufacturing in 1997 to that in 1998?
Your response must be concise. 0.97. What is the ratio of the Value added (current US$) in Services in 1997 to that in 1998?
Offer a very short reply. 0.97. What is the ratio of the Value added (current US$) of Agriculture in 1997 to that in 1998?
Ensure brevity in your answer.  1.09. What is the ratio of the Value added (current US$) in Industry in 1997 to that in 1999?
Offer a very short reply. 1.03. What is the ratio of the Value added (current US$) in Services in 1997 to that in 1999?
Provide a short and direct response. 0.97. What is the ratio of the Value added (current US$) of Agriculture in 1997 to that in 1999?
Keep it short and to the point. 1.13. What is the ratio of the Value added (current US$) of Industry in 1997 to that in 2000?
Give a very brief answer. 1.08. What is the ratio of the Value added (current US$) in Manufacturing in 1997 to that in 2000?
Your answer should be compact. 1.08. What is the ratio of the Value added (current US$) of Services in 1997 to that in 2000?
Offer a very short reply. 1.04. What is the ratio of the Value added (current US$) in Agriculture in 1997 to that in 2000?
Your answer should be very brief. 1.23. What is the ratio of the Value added (current US$) in Industry in 1997 to that in 2001?
Provide a short and direct response. 1.09. What is the ratio of the Value added (current US$) in Manufacturing in 1997 to that in 2001?
Provide a short and direct response. 1.1. What is the ratio of the Value added (current US$) of Services in 1997 to that in 2001?
Ensure brevity in your answer.  1.01. What is the ratio of the Value added (current US$) of Agriculture in 1997 to that in 2001?
Provide a short and direct response. 1.33. What is the ratio of the Value added (current US$) of Industry in 1997 to that in 2002?
Offer a very short reply. 1.02. What is the ratio of the Value added (current US$) of Manufacturing in 1997 to that in 2002?
Offer a very short reply. 1.04. What is the ratio of the Value added (current US$) of Services in 1997 to that in 2002?
Keep it short and to the point. 0.92. What is the ratio of the Value added (current US$) in Agriculture in 1997 to that in 2002?
Keep it short and to the point. 1.34. What is the ratio of the Value added (current US$) in Industry in 1998 to that in 1999?
Give a very brief answer. 1.04. What is the ratio of the Value added (current US$) in Manufacturing in 1998 to that in 1999?
Provide a short and direct response. 1.04. What is the ratio of the Value added (current US$) in Agriculture in 1998 to that in 1999?
Provide a short and direct response. 1.04. What is the ratio of the Value added (current US$) in Industry in 1998 to that in 2000?
Provide a short and direct response. 1.09. What is the ratio of the Value added (current US$) of Manufacturing in 1998 to that in 2000?
Offer a terse response. 1.12. What is the ratio of the Value added (current US$) in Services in 1998 to that in 2000?
Give a very brief answer. 1.07. What is the ratio of the Value added (current US$) of Agriculture in 1998 to that in 2000?
Your answer should be very brief. 1.13. What is the ratio of the Value added (current US$) of Industry in 1998 to that in 2001?
Offer a very short reply. 1.1. What is the ratio of the Value added (current US$) in Manufacturing in 1998 to that in 2001?
Your response must be concise. 1.14. What is the ratio of the Value added (current US$) in Services in 1998 to that in 2001?
Your response must be concise. 1.04. What is the ratio of the Value added (current US$) of Agriculture in 1998 to that in 2001?
Make the answer very short. 1.23. What is the ratio of the Value added (current US$) of Industry in 1998 to that in 2002?
Offer a very short reply. 1.02. What is the ratio of the Value added (current US$) of Manufacturing in 1998 to that in 2002?
Make the answer very short. 1.07. What is the ratio of the Value added (current US$) in Services in 1998 to that in 2002?
Your response must be concise. 0.94. What is the ratio of the Value added (current US$) in Agriculture in 1998 to that in 2002?
Provide a succinct answer. 1.24. What is the ratio of the Value added (current US$) of Industry in 1999 to that in 2000?
Offer a very short reply. 1.05. What is the ratio of the Value added (current US$) of Manufacturing in 1999 to that in 2000?
Ensure brevity in your answer.  1.08. What is the ratio of the Value added (current US$) in Services in 1999 to that in 2000?
Give a very brief answer. 1.06. What is the ratio of the Value added (current US$) of Agriculture in 1999 to that in 2000?
Your answer should be compact. 1.09. What is the ratio of the Value added (current US$) of Industry in 1999 to that in 2001?
Make the answer very short. 1.06. What is the ratio of the Value added (current US$) in Manufacturing in 1999 to that in 2001?
Ensure brevity in your answer.  1.1. What is the ratio of the Value added (current US$) in Services in 1999 to that in 2001?
Offer a terse response. 1.04. What is the ratio of the Value added (current US$) of Agriculture in 1999 to that in 2001?
Your answer should be compact. 1.18. What is the ratio of the Value added (current US$) in Industry in 1999 to that in 2002?
Your response must be concise. 0.99. What is the ratio of the Value added (current US$) of Manufacturing in 1999 to that in 2002?
Your answer should be very brief. 1.03. What is the ratio of the Value added (current US$) of Services in 1999 to that in 2002?
Provide a short and direct response. 0.94. What is the ratio of the Value added (current US$) of Agriculture in 1999 to that in 2002?
Your answer should be very brief. 1.19. What is the ratio of the Value added (current US$) of Industry in 2000 to that in 2001?
Your response must be concise. 1.01. What is the ratio of the Value added (current US$) of Manufacturing in 2000 to that in 2001?
Your answer should be compact. 1.02. What is the ratio of the Value added (current US$) of Services in 2000 to that in 2001?
Your answer should be very brief. 0.98. What is the ratio of the Value added (current US$) in Agriculture in 2000 to that in 2001?
Give a very brief answer. 1.08. What is the ratio of the Value added (current US$) in Industry in 2000 to that in 2002?
Your answer should be compact. 0.94. What is the ratio of the Value added (current US$) in Manufacturing in 2000 to that in 2002?
Provide a succinct answer. 0.96. What is the ratio of the Value added (current US$) in Services in 2000 to that in 2002?
Your answer should be very brief. 0.89. What is the ratio of the Value added (current US$) of Agriculture in 2000 to that in 2002?
Your response must be concise. 1.09. What is the ratio of the Value added (current US$) of Industry in 2001 to that in 2002?
Offer a terse response. 0.93. What is the ratio of the Value added (current US$) in Manufacturing in 2001 to that in 2002?
Make the answer very short. 0.94. What is the ratio of the Value added (current US$) in Services in 2001 to that in 2002?
Keep it short and to the point. 0.91. What is the ratio of the Value added (current US$) in Agriculture in 2001 to that in 2002?
Make the answer very short. 1.01. What is the difference between the highest and the second highest Value added (current US$) of Industry?
Offer a very short reply. 1.63e+11. What is the difference between the highest and the second highest Value added (current US$) of Manufacturing?
Your answer should be very brief. 4.05e+1. What is the difference between the highest and the second highest Value added (current US$) in Services?
Ensure brevity in your answer.  2.55e+11. What is the difference between the highest and the second highest Value added (current US$) in Agriculture?
Your response must be concise. 4.16e+09. What is the difference between the highest and the lowest Value added (current US$) in Industry?
Keep it short and to the point. 4.16e+11. What is the difference between the highest and the lowest Value added (current US$) of Manufacturing?
Keep it short and to the point. 2.66e+11. What is the difference between the highest and the lowest Value added (current US$) of Services?
Give a very brief answer. 7.91e+11. What is the difference between the highest and the lowest Value added (current US$) of Agriculture?
Provide a short and direct response. 8.15e+1. 